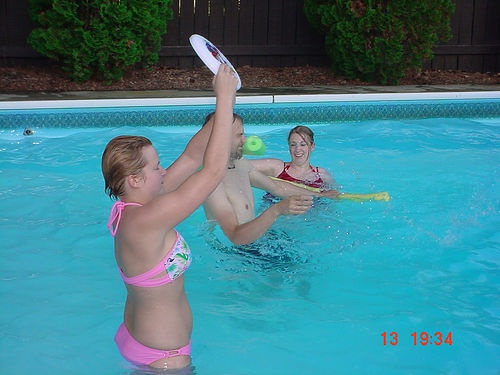Describe the objects in this image and their specific colors. I can see people in black, darkgray, and gray tones, people in black, darkgray, and gray tones, people in black, darkgray, gray, and maroon tones, and frisbee in black, lavender, and darkgray tones in this image. 